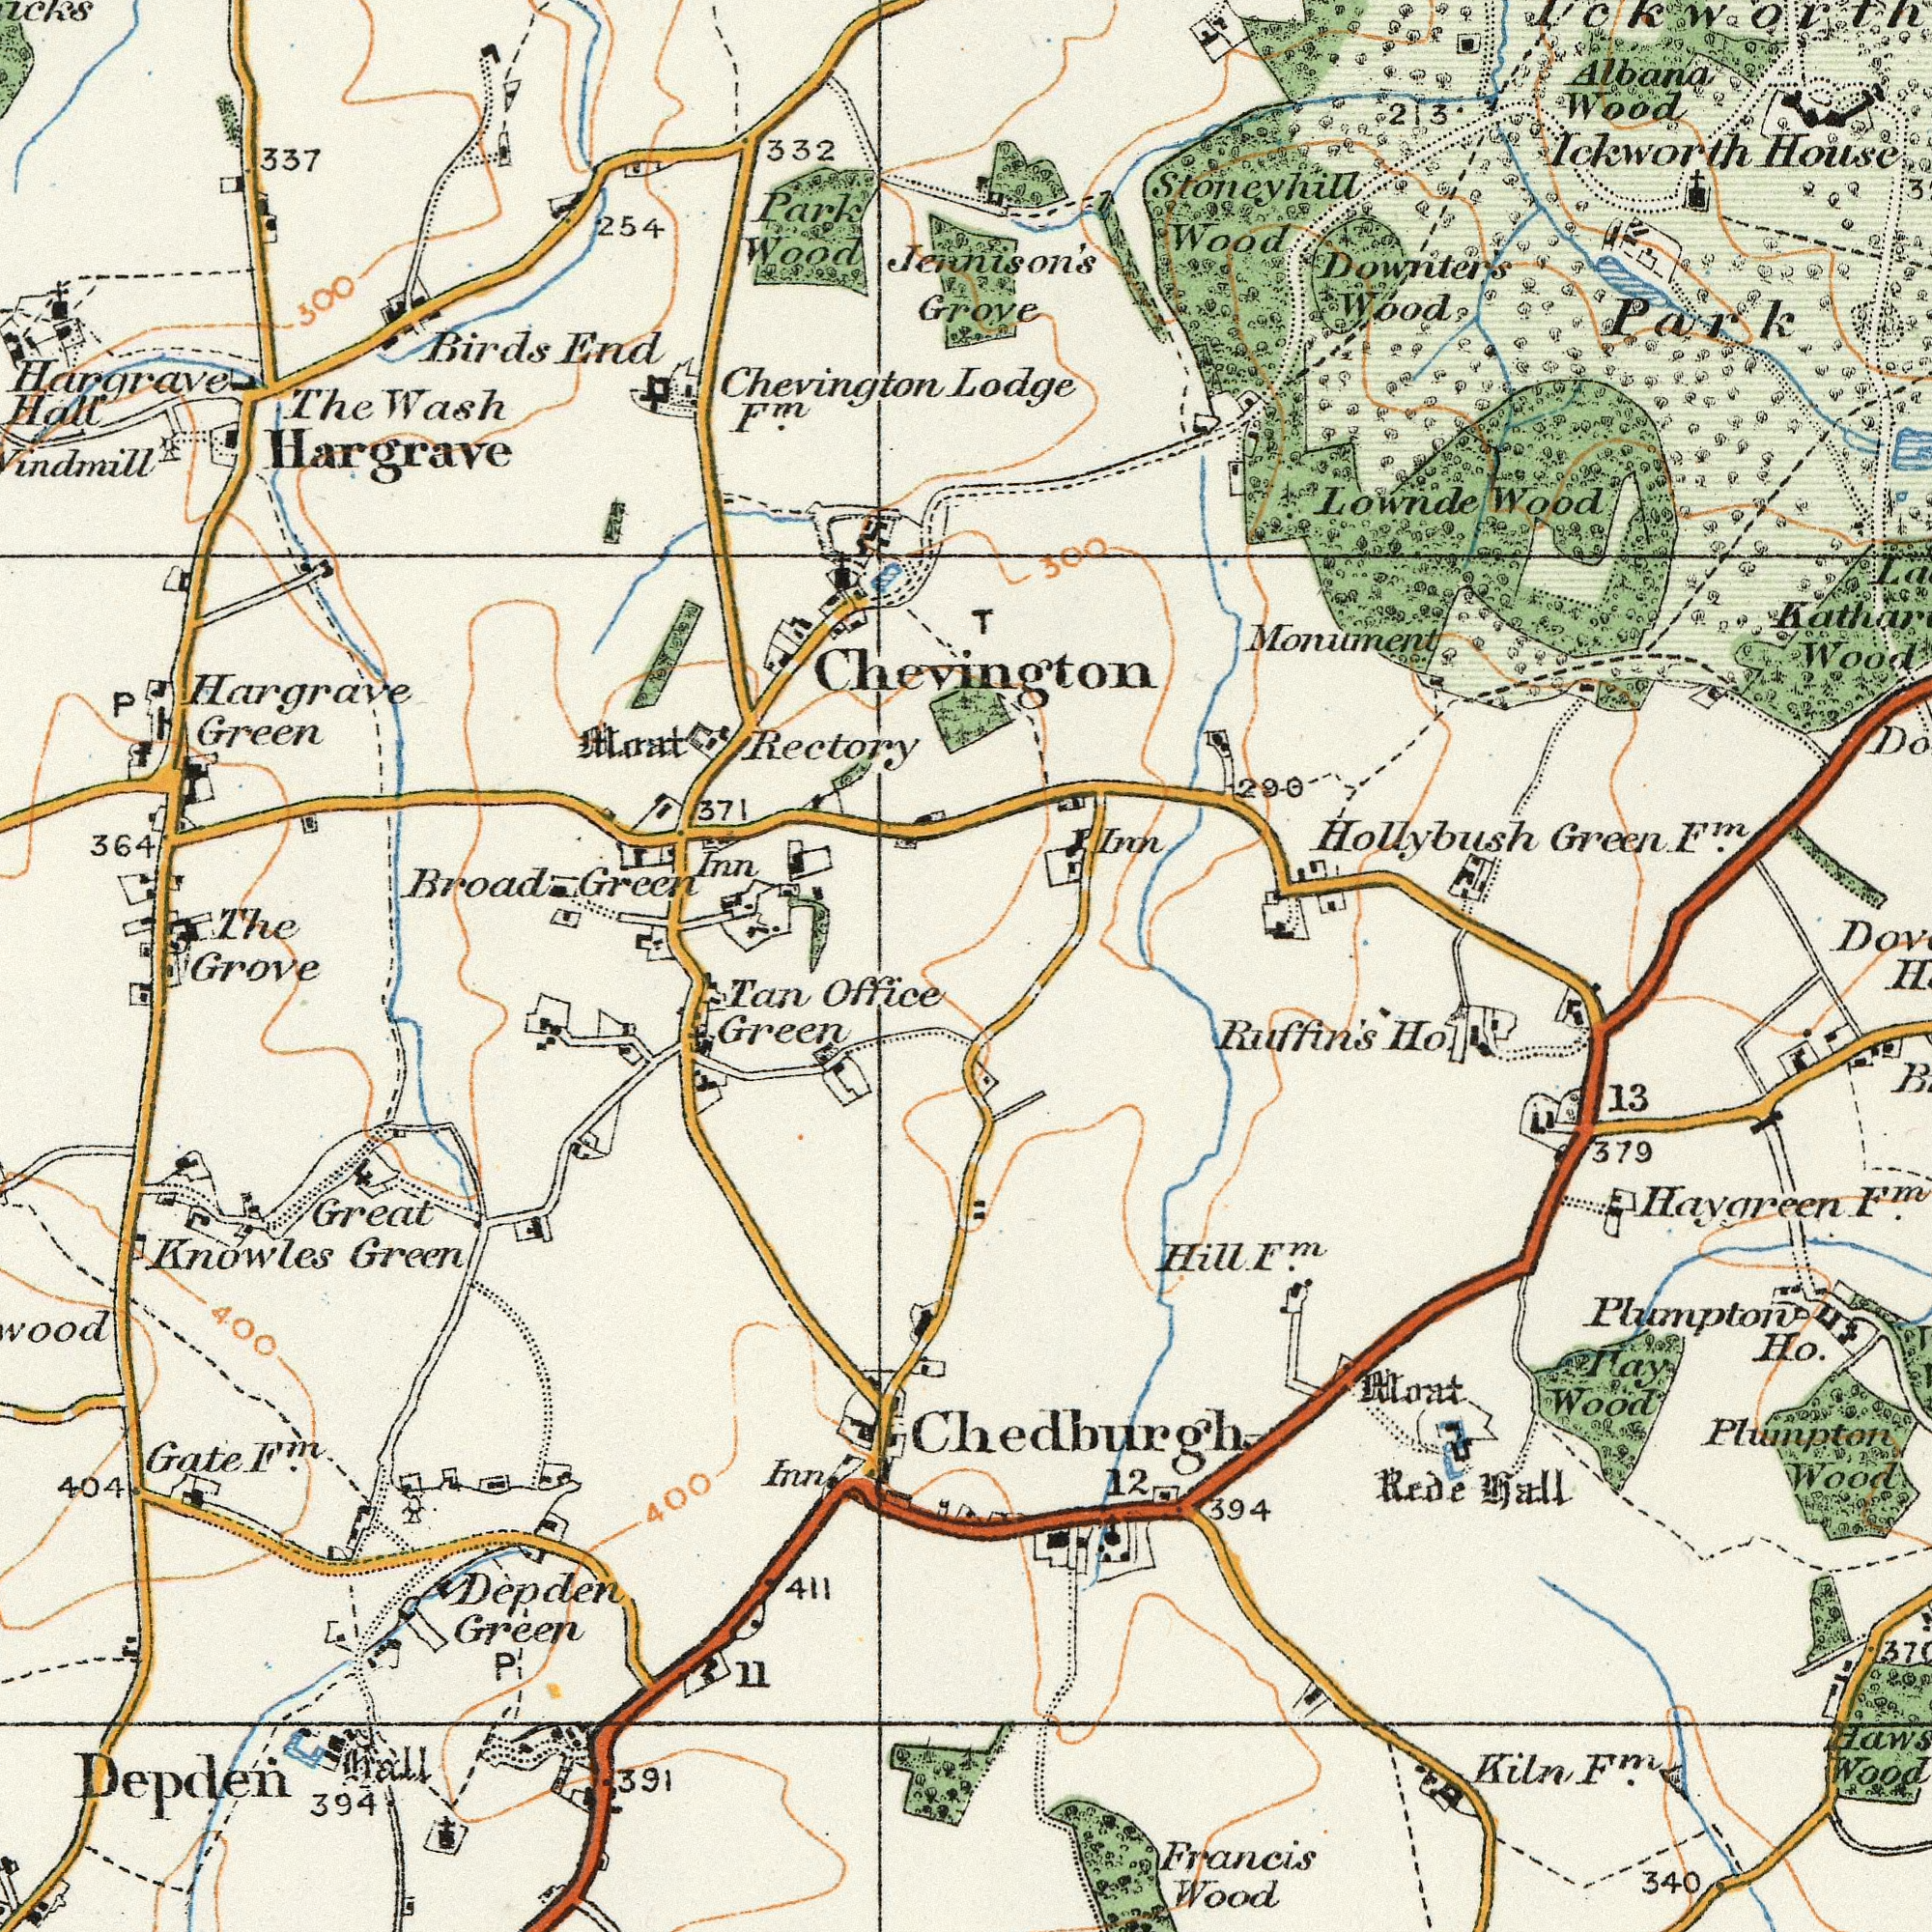What text appears in the top-right area of the image? Jennison's Grove Chevington Wood Wood Wood Green Monument Albana Wood Hollybush Wood House Downter's Ickworth 290 Park T Lodge F<sup>m</sup>. 3 Lownde 213 300 Stoneyhill Inn What text is shown in the bottom-right quadrant? Francis Wood Ruffin's 13 Ho. 340 Wood Wood Wood Haygreen 379 ###ay 394 Kiln Rede F<sup>m</sup>. Moat hall Plumpton Chedburgh 12 Hill Plumpton Ho. F<sup>m</sup>. F<sup>m</sup>. What text can you see in the bottom-left section? Depden Knowles Office Green Green Great Green Gate Depden 394 Inn 400 Tan 391 404 411 hall 11 400 F<sup>m</sup>. P What text is visible in the upper-left corner? Rectory Hargrave Hall Hargrave Broad Hargrave Wood End Green Park Green 332 The 337 Inn 254 Birds 364 Chevington Wash F<sup>m</sup>. The 371 P Moat Grove 300 